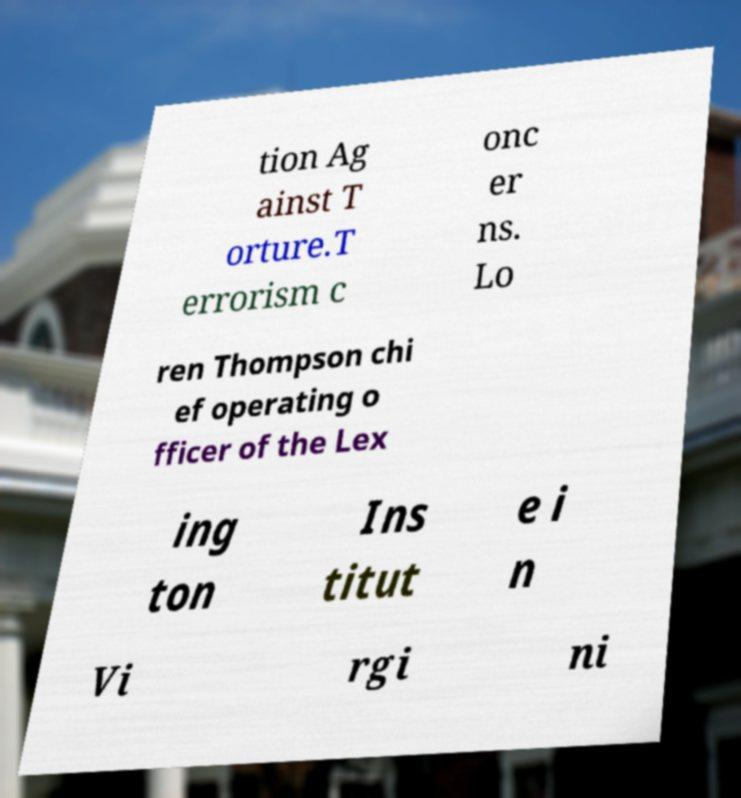Can you read and provide the text displayed in the image?This photo seems to have some interesting text. Can you extract and type it out for me? tion Ag ainst T orture.T errorism c onc er ns. Lo ren Thompson chi ef operating o fficer of the Lex ing ton Ins titut e i n Vi rgi ni 